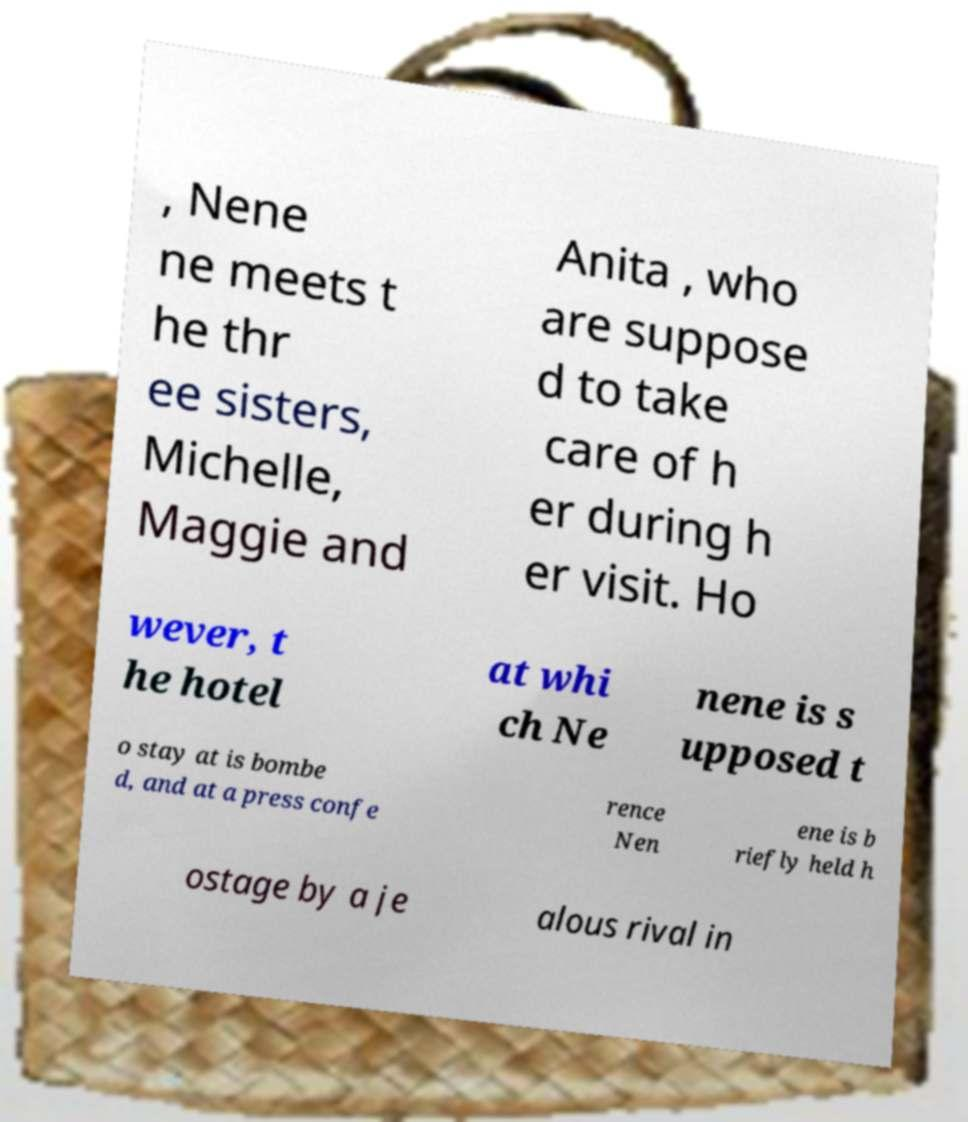Can you accurately transcribe the text from the provided image for me? , Nene ne meets t he thr ee sisters, Michelle, Maggie and Anita , who are suppose d to take care of h er during h er visit. Ho wever, t he hotel at whi ch Ne nene is s upposed t o stay at is bombe d, and at a press confe rence Nen ene is b riefly held h ostage by a je alous rival in 